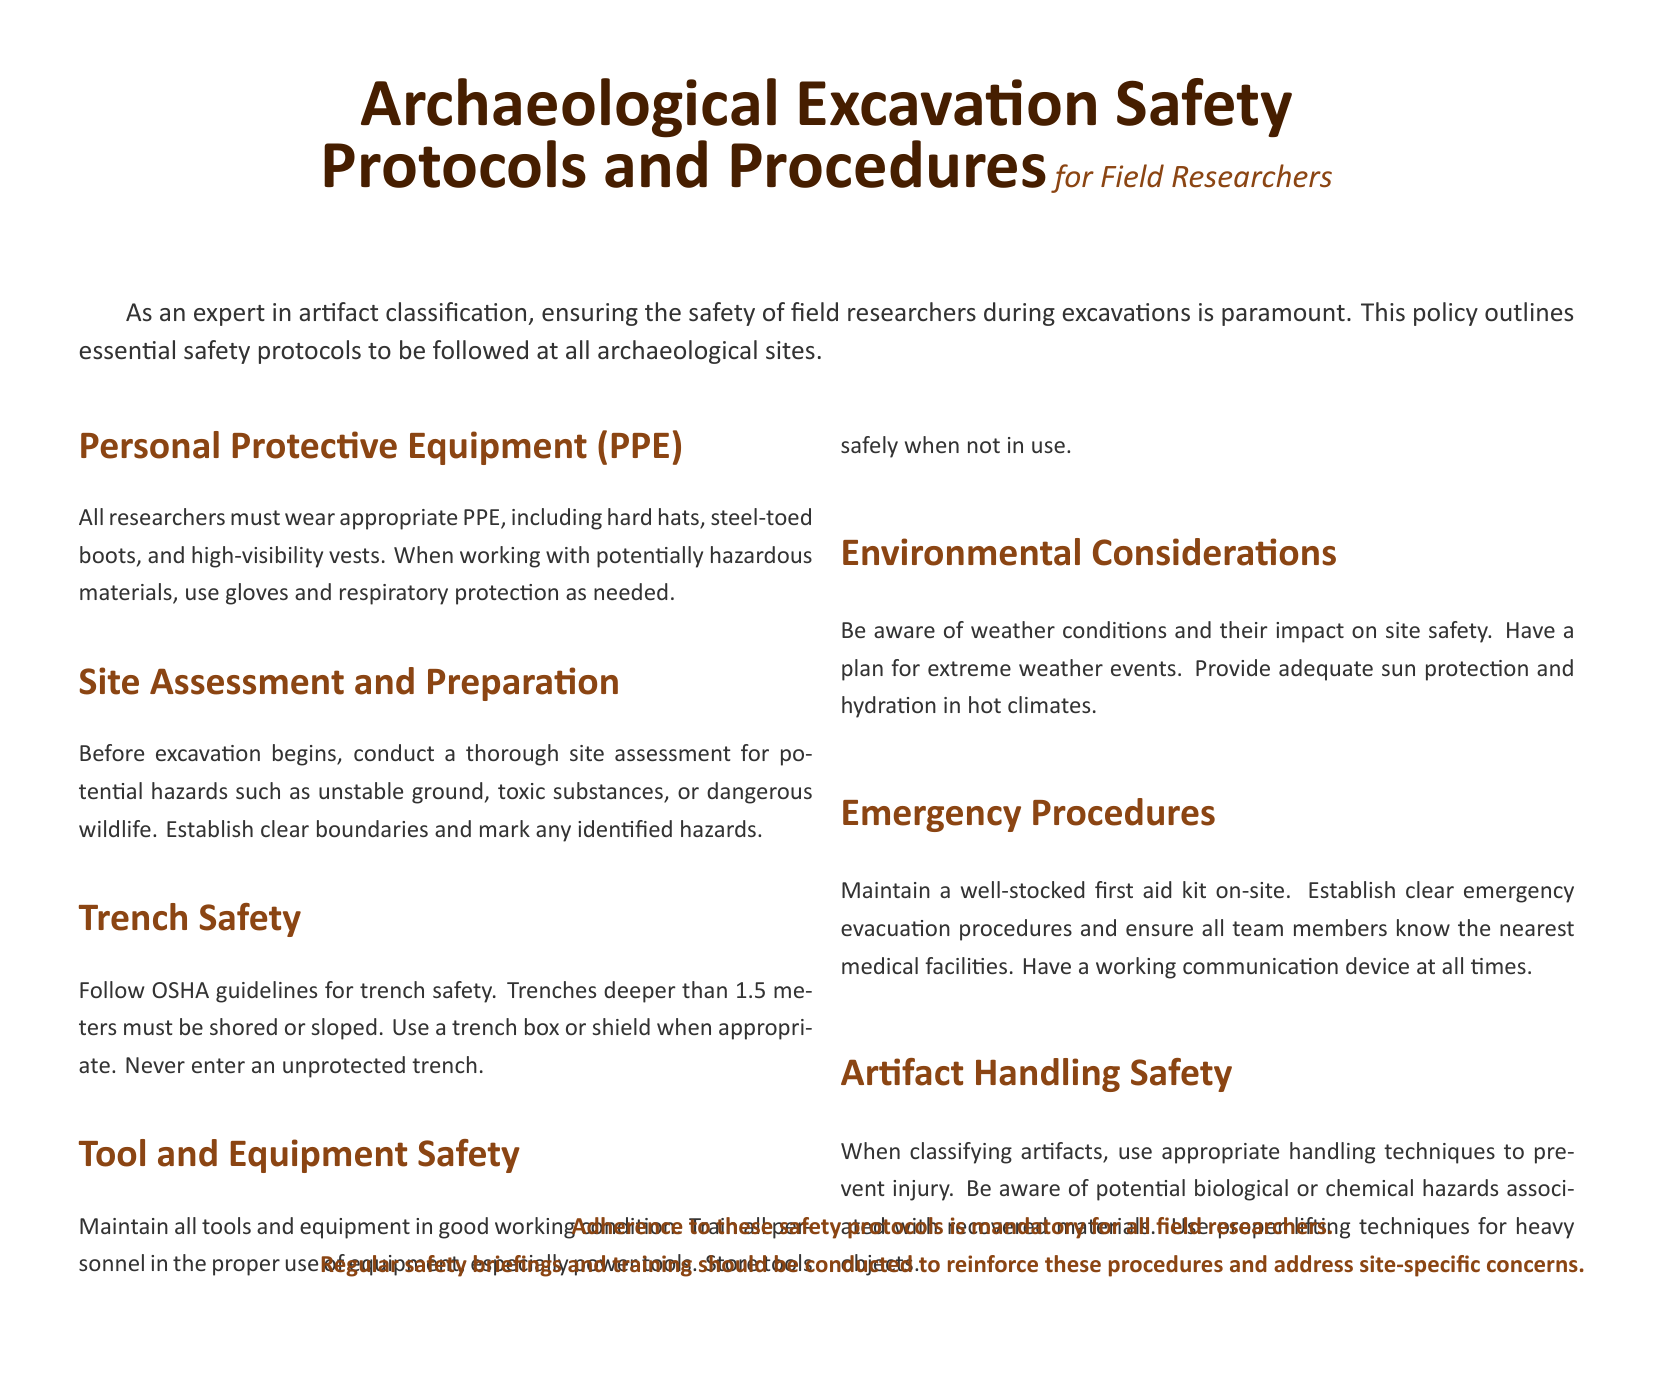What must all researchers wear? The document specifies that all researchers must wear appropriate Personal Protective Equipment, including hard hats, steel-toed boots, and high-visibility vests.
Answer: PPE What is the minimum trench depth for shoring/sloping? According to the document, trenches deeper than 1.5 meters must be shored or sloped.
Answer: 1.5 meters What should be maintained on-site for emergencies? The document states that a well-stocked first aid kit should be maintained on-site for emergencies.
Answer: First aid kit What factor should be considered for environmental safety? Researchers are advised to be aware of weather conditions and their impact on site safety.
Answer: Weather conditions What type of training should be conducted regularly? The policy mentions that regular safety briefings and training should be conducted to reinforce safety procedures.
Answer: Safety briefings What should be established before excavation begins? Before excavation begins, a thorough site assessment must be conducted for potential hazards.
Answer: Site assessment What lifting technique should be used for heavy objects? The document advises the use of proper lifting techniques when handling heavy objects.
Answer: Proper lifting techniques What type of equipment must be maintained in good working condition? All tools and equipment must be maintained in good working condition according to the policy.
Answer: Tools and equipment What should researchers have a plan for regarding weather? The document emphasizes that researchers should have a plan for extreme weather events.
Answer: Extreme weather events 